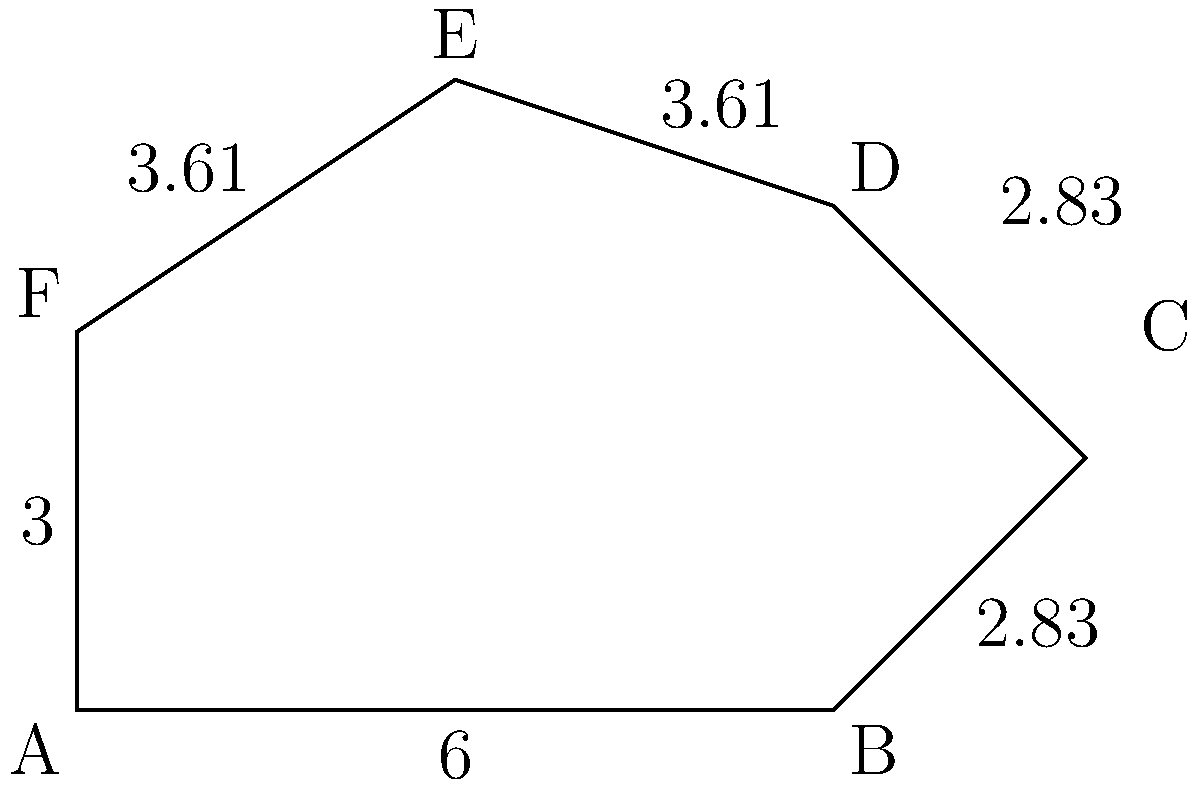In your research on anxiety disorders, you've developed a model representing the multifaceted aspects of anxiety using an irregular hexagon. Each side of the hexagon represents a different dimension of anxiety (e.g., cognitive, emotional, physical). Given the side lengths shown in the figure (in arbitrary units), what is the total perimeter of this anxiety model hexagon? To find the perimeter of the irregular hexagon, we need to sum up the lengths of all sides. Let's go through this step-by-step:

1) The bottom side (AB) has a length of 6 units.

2) The right side (BC) has a length of 2.83 units.

3) The upper-right side (CD) also has a length of 2.83 units.

4) The upper-left side (DE) has a length of 3.61 units.

5) The left side (EF) also has a length of 3.61 units.

6) The bottom-left side (FA) has a length of 3 units.

Now, let's sum up all these lengths:

$$ \text{Perimeter} = 6 + 2.83 + 2.83 + 3.61 + 3.61 + 3 $$

$$ = 21.88 \text{ units} $$

Therefore, the total perimeter of the anxiety model hexagon is 21.88 units.
Answer: 21.88 units 